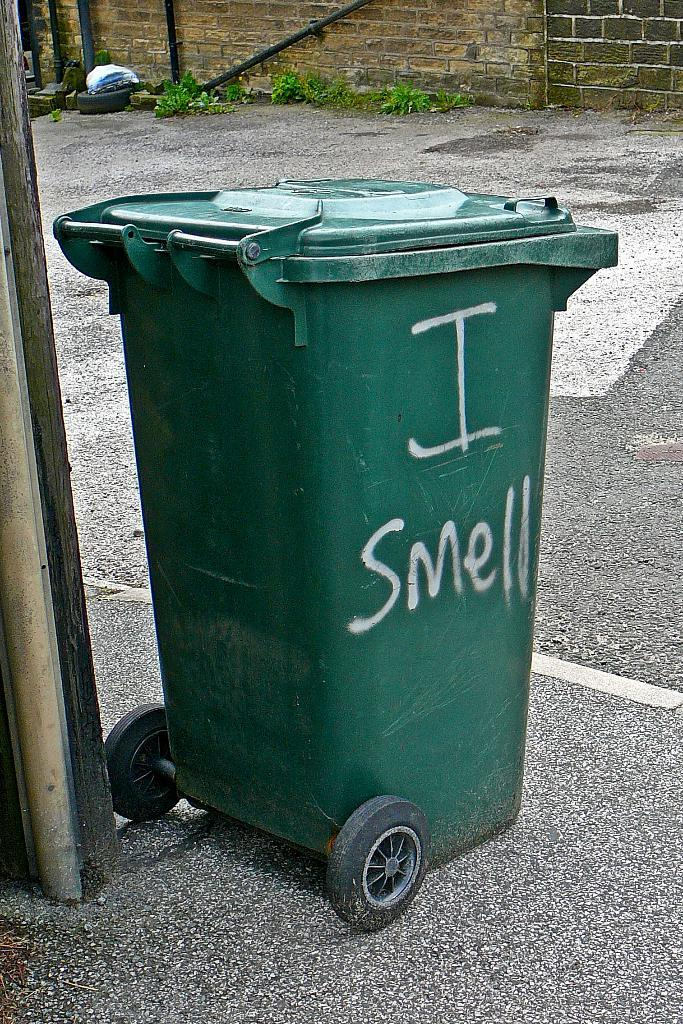<image>
Render a clear and concise summary of the photo. A green garbage dumpster with the words I Smell written on it on the side on a street 